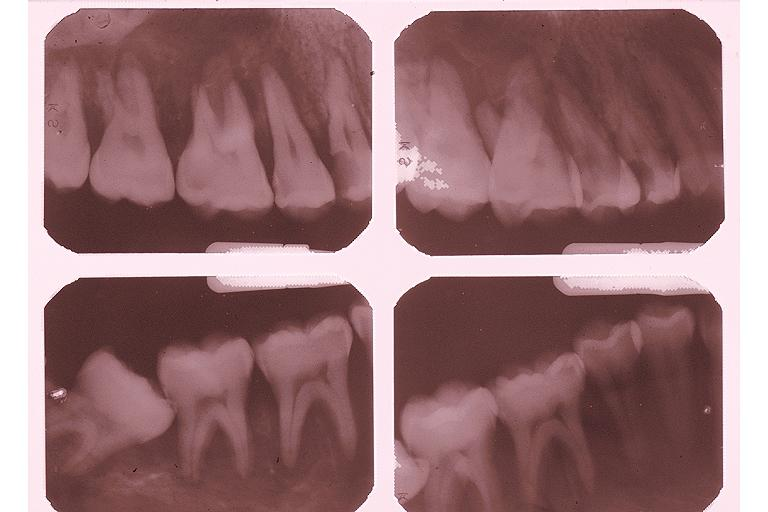where is this?
Answer the question using a single word or phrase. Oral 